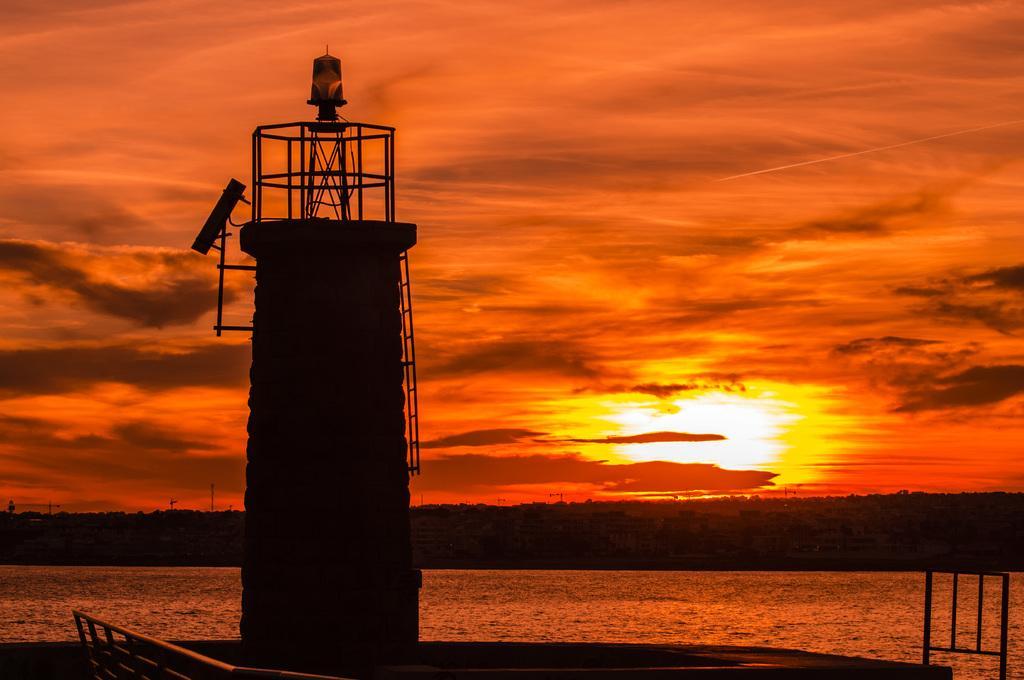Describe this image in one or two sentences. In this image there is a lighthouse, rods, water, cloudy sky and objects.   